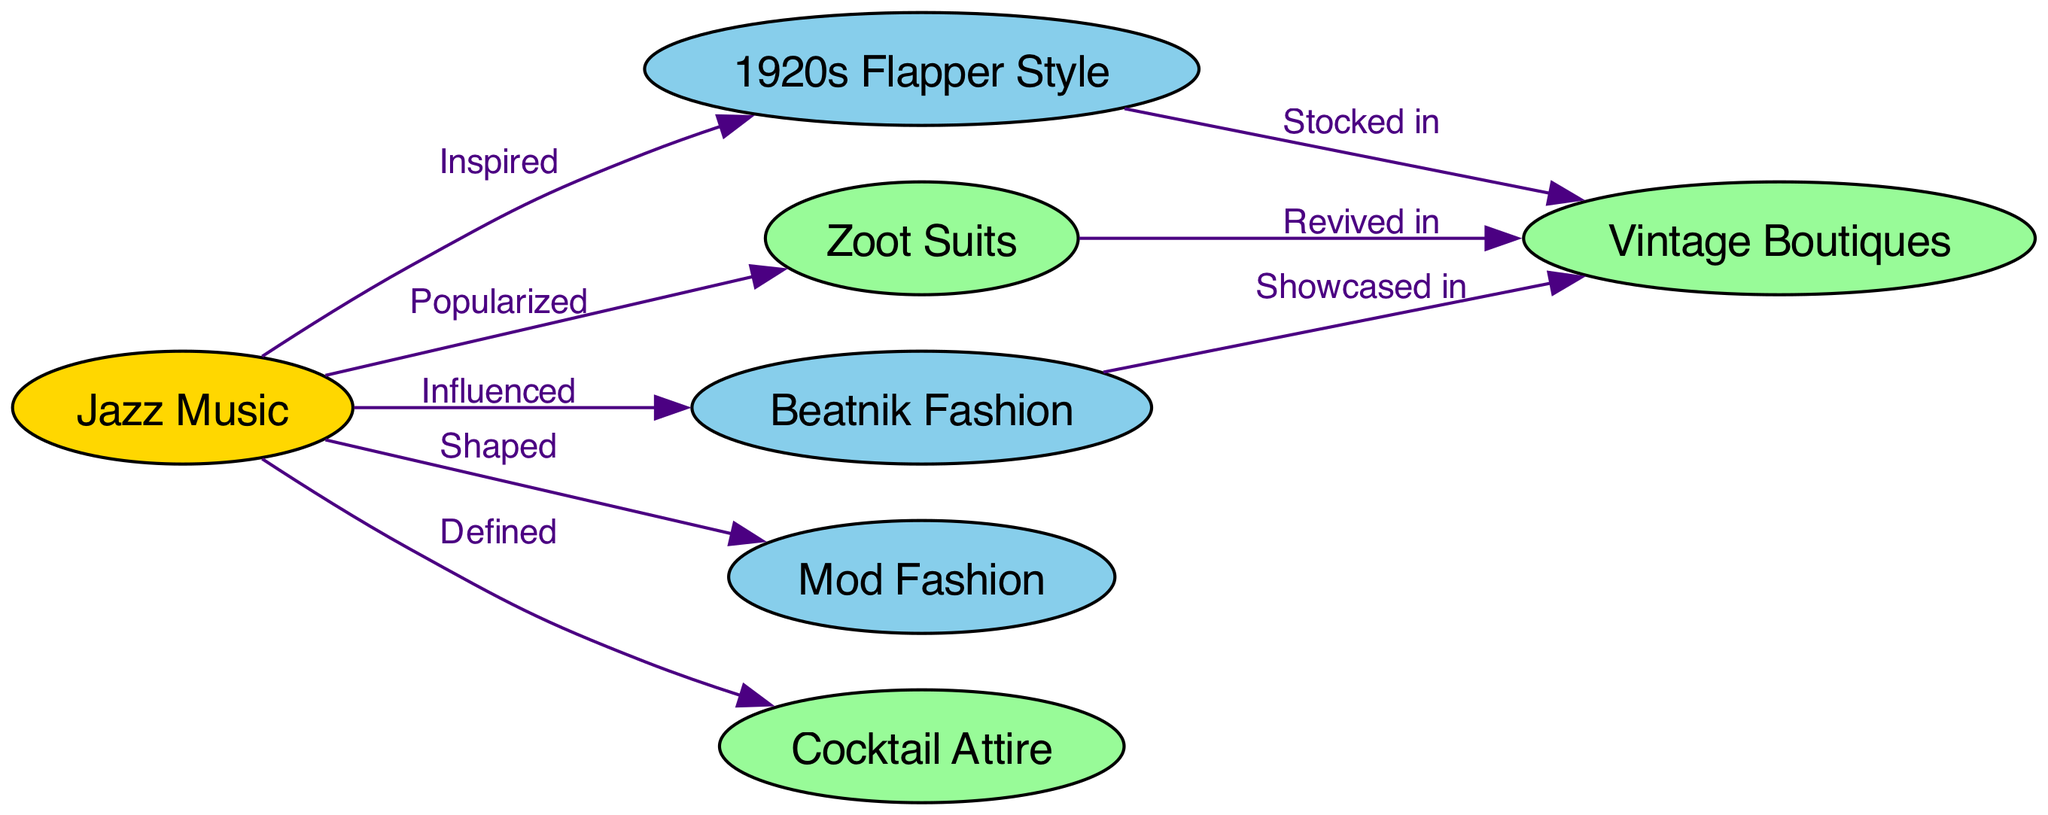What is the central node of the diagram? The central node represents the main theme or concept that influences other elements, which in this case is "Jazz Music."
Answer: Jazz Music How many nodes are in the diagram? Counting all the unique nodes listed provides the total number, which is seven (Jazz Music, 1920s Flapper Style, Zoot Suits, Beatnik Fashion, Mod Fashion, Cocktail Attire, Vintage Boutiques).
Answer: 7 What fashion style did Jazz Music inspire? The directed edge shows that Jazz Music is connected to 1920s Flapper Style and indicates a direct influence, thus the answer is 1920s Flapper Style.
Answer: 1920s Flapper Style Which styles are showcased in Vintage Boutiques? By looking at the directed edges, you can identify that Vintage Boutiques feature 1920s Flapper Style, Zoot Suits, and Beatnik Fashion, indicating multiple styles are showcased.
Answer: 1920s Flapper Style, Zoot Suits, Beatnik Fashion What term describes the relationship between Jazz Music and Cocktail Attire? The directed edge relationship shows that Jazz Music "Defined" Cocktail Attire, indicating how one influences the nature of the other.
Answer: Defined Which fashion style is popularized by Jazz Music? The diagram directly connects Jazz Music to Zoot Suits, using the label "Popularized," which indicates the influence clearly.
Answer: Zoot Suits How are 1920s Flapper Styles connected to Vintage Boutiques? There is a directed edge showing that 1920s Flapper Style is "Stocked in" Vintage Boutiques, indicating that these boutiques carry that specific style.
Answer: Stocked in How does Jazz Music shape Mod Fashion? The edge labeled "Shaped" between Jazz Music and Mod Fashion shows that Jazz Music has a formative effect on the evolution of Mod Fashion.
Answer: Shaped How many relationships are there in total? By counting the directed edges listed, we can identify there are eight clear relationships between different nodes in the diagram.
Answer: 8 